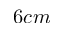Convert formula to latex. <formula><loc_0><loc_0><loc_500><loc_500>6 c m</formula> 